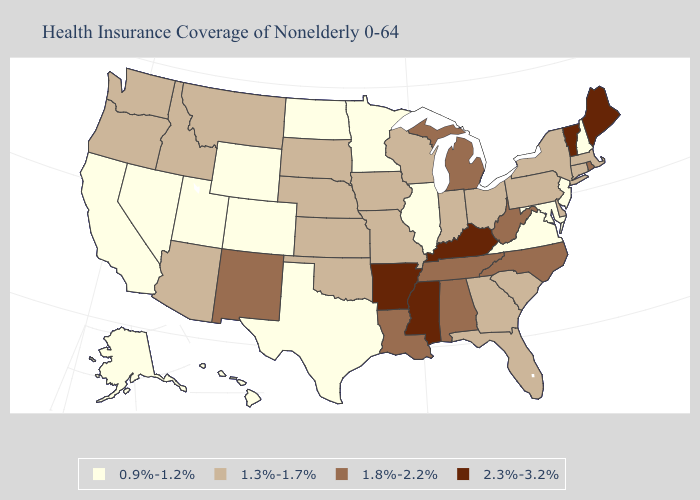Does Rhode Island have a lower value than Michigan?
Keep it brief. No. Does Mississippi have a lower value than Montana?
Keep it brief. No. Name the states that have a value in the range 1.3%-1.7%?
Short answer required. Arizona, Connecticut, Delaware, Florida, Georgia, Idaho, Indiana, Iowa, Kansas, Massachusetts, Missouri, Montana, Nebraska, New York, Ohio, Oklahoma, Oregon, Pennsylvania, South Carolina, South Dakota, Washington, Wisconsin. Name the states that have a value in the range 2.3%-3.2%?
Give a very brief answer. Arkansas, Kentucky, Maine, Mississippi, Vermont. What is the lowest value in states that border Maine?
Concise answer only. 0.9%-1.2%. Does Minnesota have the lowest value in the USA?
Be succinct. Yes. Among the states that border Arizona , does New Mexico have the lowest value?
Write a very short answer. No. What is the value of Alabama?
Be succinct. 1.8%-2.2%. What is the value of Connecticut?
Concise answer only. 1.3%-1.7%. Name the states that have a value in the range 0.9%-1.2%?
Be succinct. Alaska, California, Colorado, Hawaii, Illinois, Maryland, Minnesota, Nevada, New Hampshire, New Jersey, North Dakota, Texas, Utah, Virginia, Wyoming. Is the legend a continuous bar?
Short answer required. No. What is the value of Connecticut?
Short answer required. 1.3%-1.7%. Does Virginia have the lowest value in the South?
Answer briefly. Yes. Does California have the same value as Delaware?
Short answer required. No. 